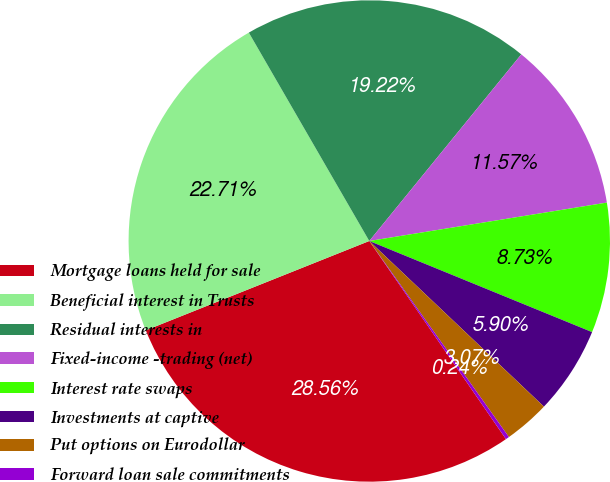Convert chart. <chart><loc_0><loc_0><loc_500><loc_500><pie_chart><fcel>Mortgage loans held for sale<fcel>Beneficial interest in Trusts<fcel>Residual interests in<fcel>Fixed-income -trading (net)<fcel>Interest rate swaps<fcel>Investments at captive<fcel>Put options on Eurodollar<fcel>Forward loan sale commitments<nl><fcel>28.56%<fcel>22.71%<fcel>19.22%<fcel>11.57%<fcel>8.73%<fcel>5.9%<fcel>3.07%<fcel>0.24%<nl></chart> 